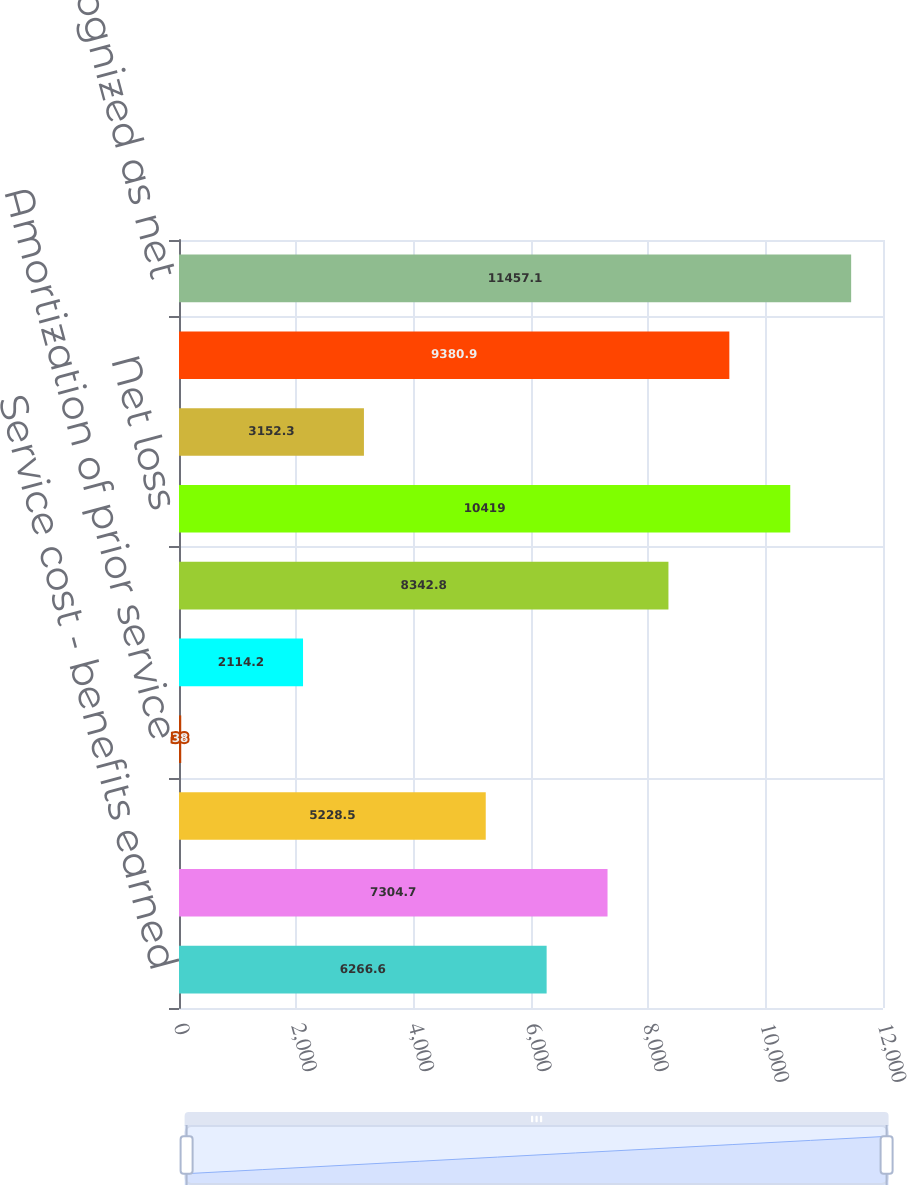Convert chart. <chart><loc_0><loc_0><loc_500><loc_500><bar_chart><fcel>Service cost - benefits earned<fcel>Interest cost on APBO<fcel>Amortization of transition<fcel>Amortization of prior service<fcel>Recognized net loss<fcel>Net other postretirement<fcel>Net loss<fcel>Amortization of net loss<fcel>Total<fcel>Total recognized as net<nl><fcel>6266.6<fcel>7304.7<fcel>5228.5<fcel>38<fcel>2114.2<fcel>8342.8<fcel>10419<fcel>3152.3<fcel>9380.9<fcel>11457.1<nl></chart> 